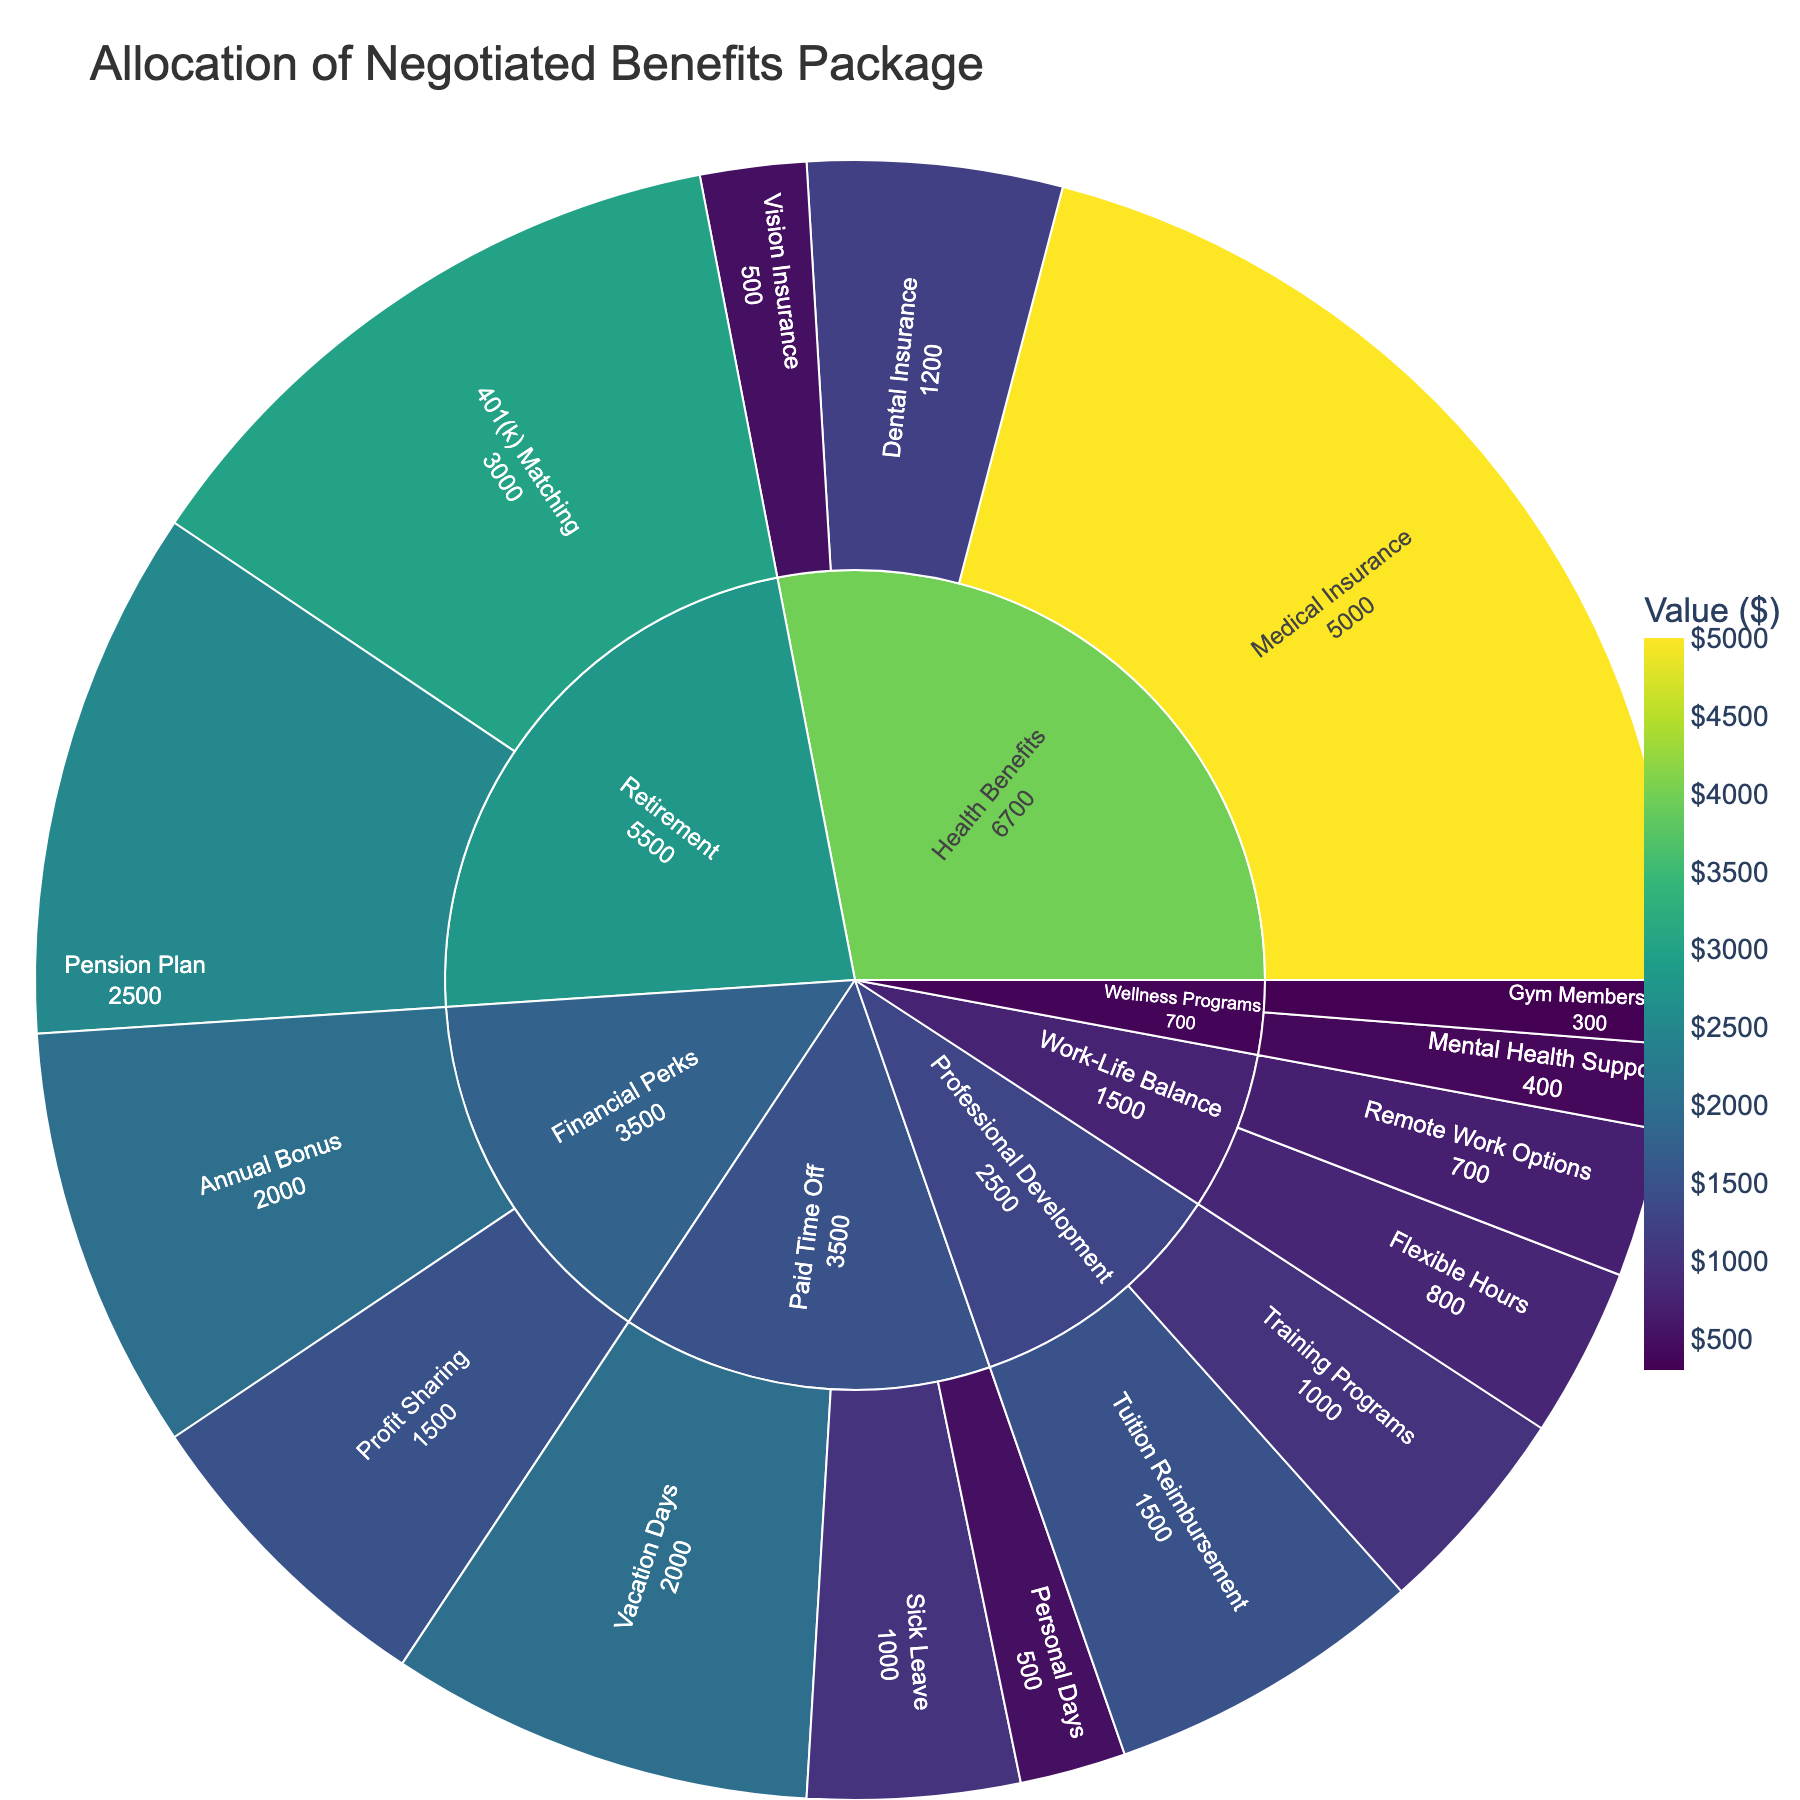What's the title of the sunburst plot? The title of the sunburst plot is displayed at the top of the figure, indicating the main topic being visualized.
Answer: Allocation of Negotiated Benefits Package What category has the highest allocation? To find the category with the highest allocation, look at the segments on the outer ring and see which one has the largest value.
Answer: Health Benefits What is the total value allocated to Paid Time Off? Add up the values of all subcategories within the Paid Time Off category: Vacation Days (2000), Sick Leave (1000), and Personal Days (500). Total = 2000 + 1000 + 500.
Answer: 3500 Which subcategory in Retirement has a higher value, 401(k) Matching or Pension Plan? Compare the values of 401(k) Matching (3000) and Pension Plan (2500) directly.
Answer: 401(k) Matching How much more is allocated to Medical Insurance compared to Vision Insurance? Subtract the value of Vision Insurance (500) from the value of Medical Insurance (5000).
Answer: 4500 What is the combined value of Financial Perks and Wellness Programs? Add the total value of Financial Perks (Annual Bonus 2000 + Profit Sharing 1500) and Wellness Programs (Gym Membership 300 + Mental Health Support 400). Total = 2000 + 1500 + 300 + 400.
Answer: 4200 What is the value allocated to Remote Work Options? Look for the value associated with the Remote Work Options subcategory within the Work-Life Balance category.
Answer: 700 Is the value for Flexible Hours higher or lower than for Gym Membership? Compare the values for Flexible Hours (800) and Gym Membership (300).
Answer: Higher Which category has the smallest single subcategory value, and what is that value? Look for the smallest value among all subcategories in each category. The smallest value is within Wellness Programs (Gym Membership 300).
Answer: Wellness Programs, $300 